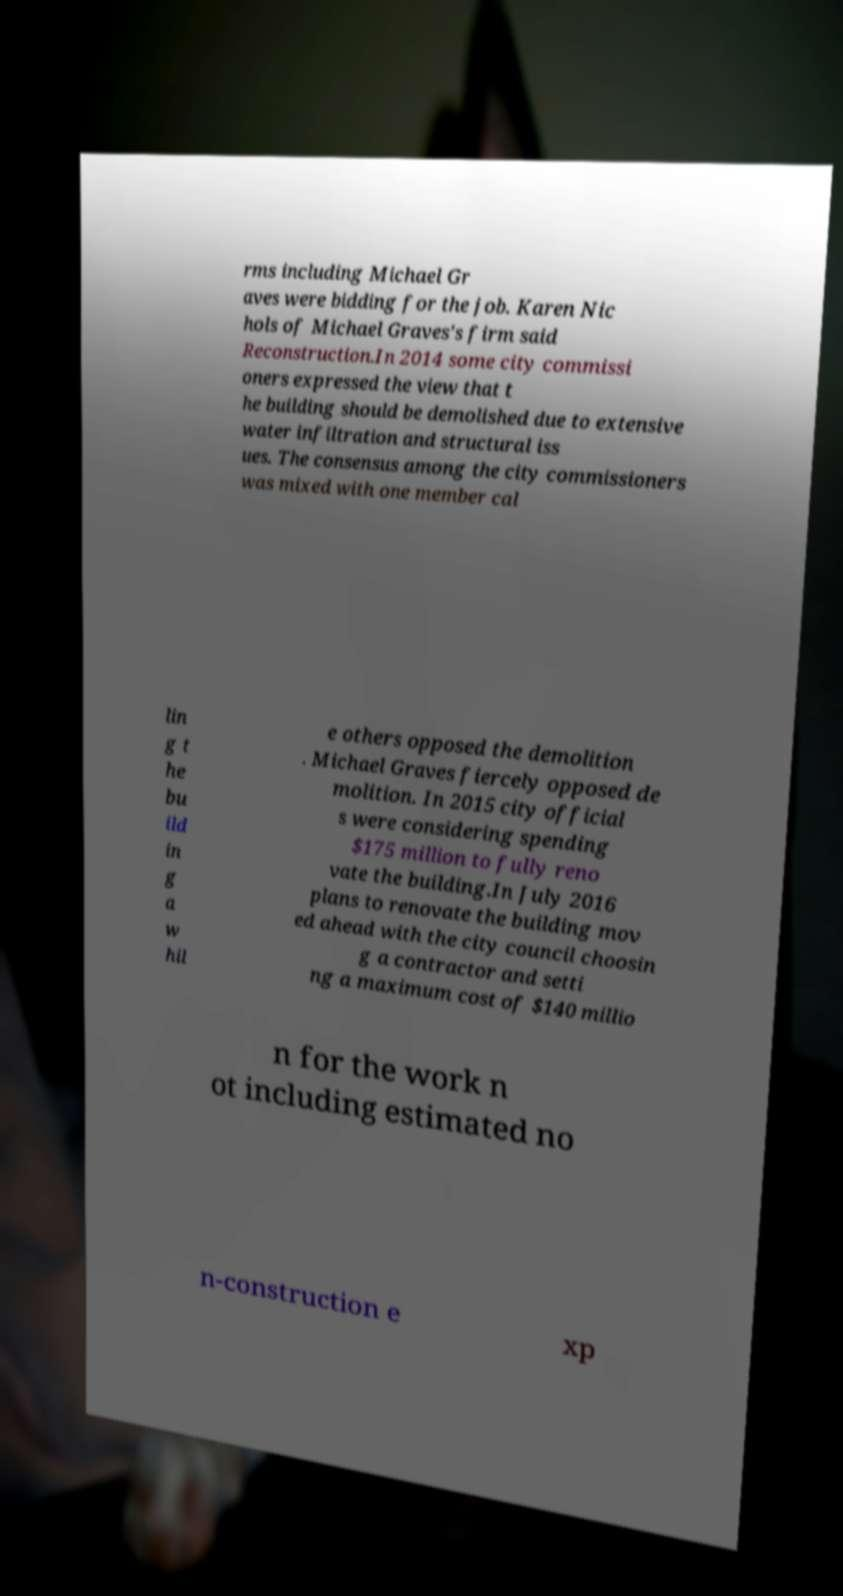Could you assist in decoding the text presented in this image and type it out clearly? rms including Michael Gr aves were bidding for the job. Karen Nic hols of Michael Graves's firm said Reconstruction.In 2014 some city commissi oners expressed the view that t he building should be demolished due to extensive water infiltration and structural iss ues. The consensus among the city commissioners was mixed with one member cal lin g t he bu ild in g a w hil e others opposed the demolition . Michael Graves fiercely opposed de molition. In 2015 city official s were considering spending $175 million to fully reno vate the building.In July 2016 plans to renovate the building mov ed ahead with the city council choosin g a contractor and setti ng a maximum cost of $140 millio n for the work n ot including estimated no n-construction e xp 